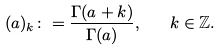<formula> <loc_0><loc_0><loc_500><loc_500>( a ) _ { k } \colon = \frac { \Gamma ( a + k ) } { \Gamma ( a ) } , \quad k \in \mathbb { Z } .</formula> 